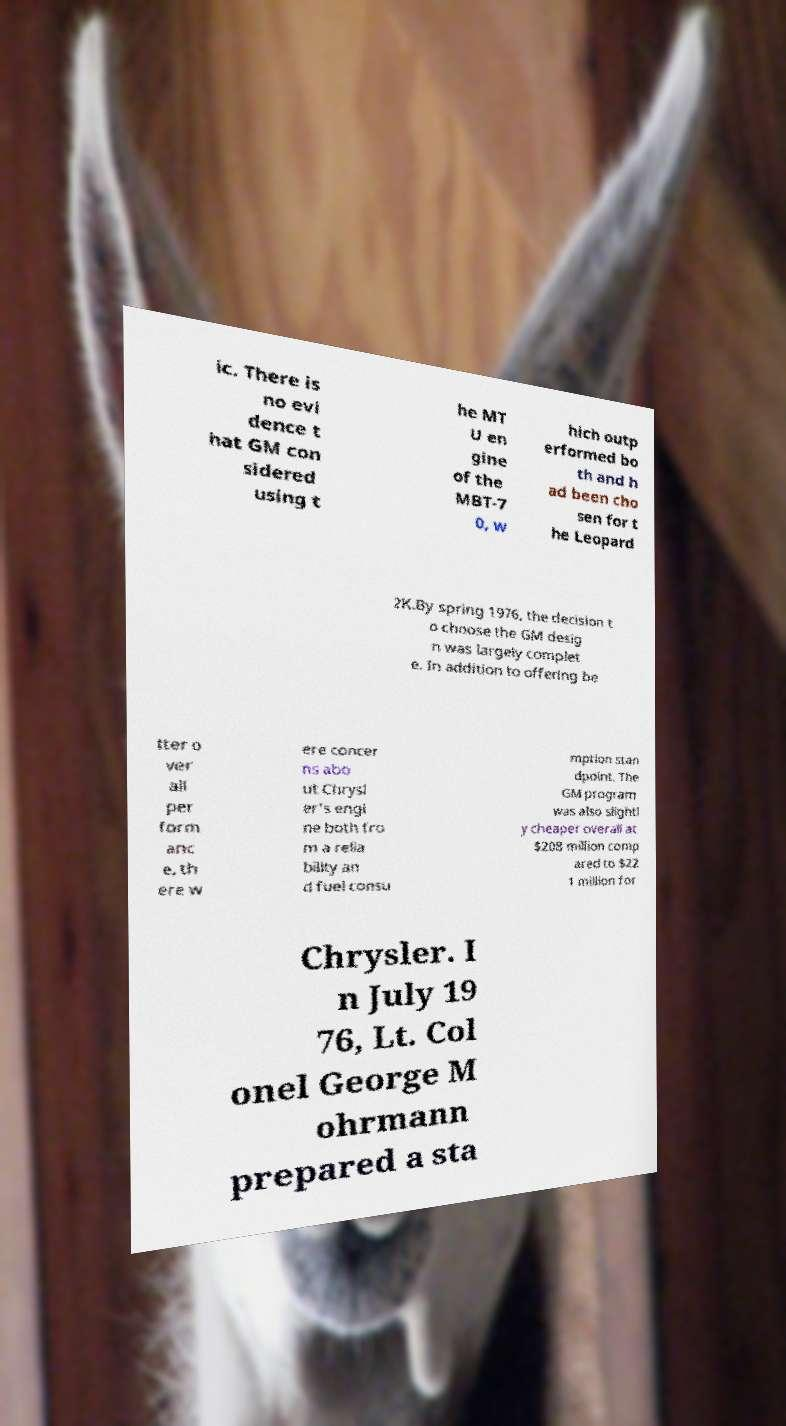Can you accurately transcribe the text from the provided image for me? ic. There is no evi dence t hat GM con sidered using t he MT U en gine of the MBT-7 0, w hich outp erformed bo th and h ad been cho sen for t he Leopard 2K.By spring 1976, the decision t o choose the GM desig n was largely complet e. In addition to offering be tter o ver all per form anc e, th ere w ere concer ns abo ut Chrysl er's engi ne both fro m a relia bility an d fuel consu mption stan dpoint. The GM program was also slightl y cheaper overall at $208 million comp ared to $22 1 million for Chrysler. I n July 19 76, Lt. Col onel George M ohrmann prepared a sta 